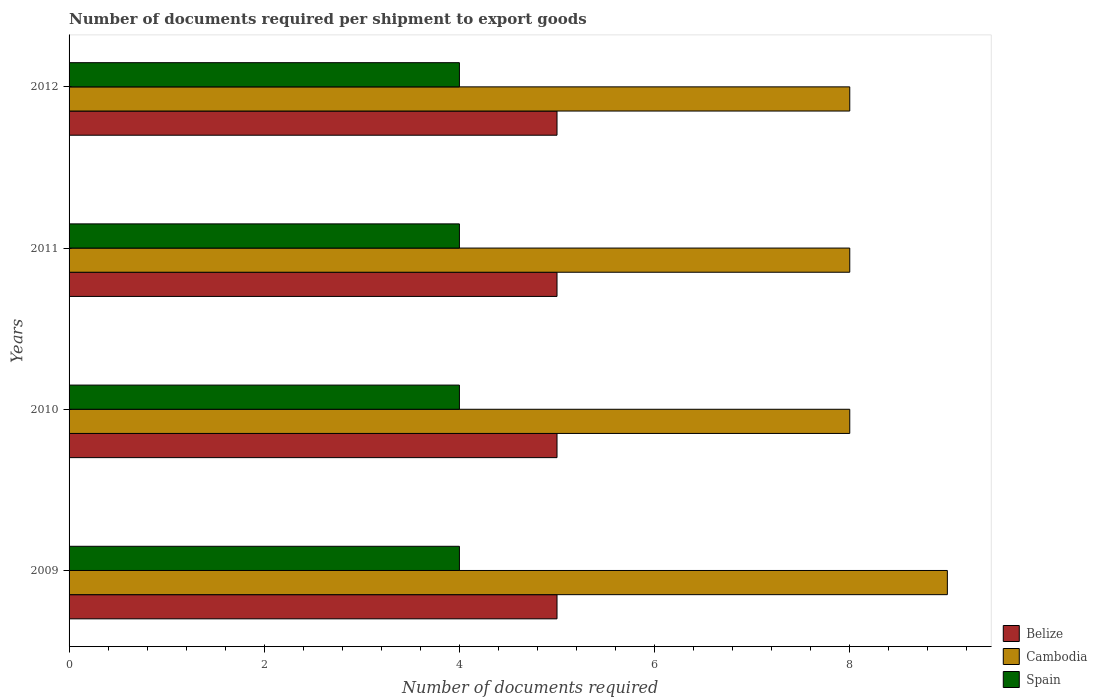How many groups of bars are there?
Your answer should be very brief. 4. Are the number of bars per tick equal to the number of legend labels?
Offer a very short reply. Yes. How many bars are there on the 2nd tick from the top?
Your answer should be very brief. 3. In how many cases, is the number of bars for a given year not equal to the number of legend labels?
Ensure brevity in your answer.  0. What is the number of documents required per shipment to export goods in Spain in 2012?
Your answer should be very brief. 4. Across all years, what is the maximum number of documents required per shipment to export goods in Belize?
Offer a terse response. 5. Across all years, what is the minimum number of documents required per shipment to export goods in Cambodia?
Make the answer very short. 8. In which year was the number of documents required per shipment to export goods in Belize maximum?
Your answer should be very brief. 2009. In which year was the number of documents required per shipment to export goods in Cambodia minimum?
Provide a succinct answer. 2010. What is the total number of documents required per shipment to export goods in Cambodia in the graph?
Provide a succinct answer. 33. What is the difference between the number of documents required per shipment to export goods in Cambodia in 2009 and that in 2010?
Give a very brief answer. 1. What is the difference between the number of documents required per shipment to export goods in Belize in 2010 and the number of documents required per shipment to export goods in Spain in 2011?
Provide a succinct answer. 1. In the year 2010, what is the difference between the number of documents required per shipment to export goods in Spain and number of documents required per shipment to export goods in Cambodia?
Your response must be concise. -4. In how many years, is the number of documents required per shipment to export goods in Belize greater than 3.6 ?
Provide a succinct answer. 4. Is the number of documents required per shipment to export goods in Cambodia in 2009 less than that in 2010?
Offer a very short reply. No. Is the difference between the number of documents required per shipment to export goods in Spain in 2010 and 2012 greater than the difference between the number of documents required per shipment to export goods in Cambodia in 2010 and 2012?
Keep it short and to the point. No. In how many years, is the number of documents required per shipment to export goods in Belize greater than the average number of documents required per shipment to export goods in Belize taken over all years?
Give a very brief answer. 0. What does the 2nd bar from the top in 2012 represents?
Your response must be concise. Cambodia. What does the 1st bar from the bottom in 2011 represents?
Provide a short and direct response. Belize. Is it the case that in every year, the sum of the number of documents required per shipment to export goods in Spain and number of documents required per shipment to export goods in Cambodia is greater than the number of documents required per shipment to export goods in Belize?
Offer a terse response. Yes. What is the difference between two consecutive major ticks on the X-axis?
Keep it short and to the point. 2. Where does the legend appear in the graph?
Keep it short and to the point. Bottom right. How are the legend labels stacked?
Ensure brevity in your answer.  Vertical. What is the title of the graph?
Ensure brevity in your answer.  Number of documents required per shipment to export goods. Does "Guatemala" appear as one of the legend labels in the graph?
Keep it short and to the point. No. What is the label or title of the X-axis?
Make the answer very short. Number of documents required. What is the label or title of the Y-axis?
Your answer should be very brief. Years. What is the Number of documents required in Belize in 2009?
Make the answer very short. 5. What is the Number of documents required of Spain in 2009?
Your answer should be very brief. 4. What is the Number of documents required in Belize in 2010?
Your answer should be very brief. 5. What is the Number of documents required of Spain in 2010?
Your answer should be very brief. 4. What is the Number of documents required in Belize in 2011?
Make the answer very short. 5. What is the Number of documents required in Cambodia in 2011?
Ensure brevity in your answer.  8. What is the Number of documents required in Belize in 2012?
Offer a very short reply. 5. What is the Number of documents required of Spain in 2012?
Give a very brief answer. 4. Across all years, what is the maximum Number of documents required of Belize?
Your response must be concise. 5. Across all years, what is the maximum Number of documents required of Cambodia?
Make the answer very short. 9. Across all years, what is the maximum Number of documents required of Spain?
Your answer should be very brief. 4. Across all years, what is the minimum Number of documents required in Spain?
Your response must be concise. 4. What is the total Number of documents required of Cambodia in the graph?
Make the answer very short. 33. What is the difference between the Number of documents required in Belize in 2009 and that in 2010?
Make the answer very short. 0. What is the difference between the Number of documents required of Belize in 2009 and that in 2011?
Your answer should be compact. 0. What is the difference between the Number of documents required of Cambodia in 2009 and that in 2011?
Your response must be concise. 1. What is the difference between the Number of documents required in Belize in 2009 and that in 2012?
Your answer should be compact. 0. What is the difference between the Number of documents required of Spain in 2010 and that in 2011?
Provide a succinct answer. 0. What is the difference between the Number of documents required in Cambodia in 2009 and the Number of documents required in Spain in 2010?
Offer a terse response. 5. What is the difference between the Number of documents required of Belize in 2009 and the Number of documents required of Cambodia in 2011?
Your answer should be compact. -3. What is the difference between the Number of documents required in Belize in 2009 and the Number of documents required in Spain in 2011?
Your answer should be very brief. 1. What is the difference between the Number of documents required of Cambodia in 2009 and the Number of documents required of Spain in 2011?
Ensure brevity in your answer.  5. What is the difference between the Number of documents required in Belize in 2009 and the Number of documents required in Spain in 2012?
Offer a terse response. 1. What is the difference between the Number of documents required in Belize in 2010 and the Number of documents required in Spain in 2011?
Provide a short and direct response. 1. What is the difference between the Number of documents required of Belize in 2010 and the Number of documents required of Cambodia in 2012?
Your answer should be very brief. -3. What is the difference between the Number of documents required in Cambodia in 2010 and the Number of documents required in Spain in 2012?
Offer a very short reply. 4. What is the difference between the Number of documents required in Belize in 2011 and the Number of documents required in Spain in 2012?
Ensure brevity in your answer.  1. What is the average Number of documents required in Cambodia per year?
Offer a terse response. 8.25. What is the average Number of documents required in Spain per year?
Your response must be concise. 4. In the year 2009, what is the difference between the Number of documents required of Belize and Number of documents required of Cambodia?
Your response must be concise. -4. In the year 2009, what is the difference between the Number of documents required in Cambodia and Number of documents required in Spain?
Provide a succinct answer. 5. In the year 2010, what is the difference between the Number of documents required of Belize and Number of documents required of Spain?
Keep it short and to the point. 1. In the year 2010, what is the difference between the Number of documents required of Cambodia and Number of documents required of Spain?
Offer a terse response. 4. In the year 2011, what is the difference between the Number of documents required of Belize and Number of documents required of Cambodia?
Offer a very short reply. -3. In the year 2011, what is the difference between the Number of documents required in Belize and Number of documents required in Spain?
Your answer should be compact. 1. In the year 2012, what is the difference between the Number of documents required of Belize and Number of documents required of Cambodia?
Provide a short and direct response. -3. What is the ratio of the Number of documents required in Belize in 2009 to that in 2010?
Your response must be concise. 1. What is the ratio of the Number of documents required of Spain in 2009 to that in 2010?
Your response must be concise. 1. What is the ratio of the Number of documents required in Cambodia in 2009 to that in 2012?
Your response must be concise. 1.12. What is the ratio of the Number of documents required in Cambodia in 2010 to that in 2011?
Your answer should be compact. 1. What is the ratio of the Number of documents required of Spain in 2010 to that in 2011?
Offer a terse response. 1. What is the ratio of the Number of documents required in Cambodia in 2010 to that in 2012?
Your response must be concise. 1. What is the ratio of the Number of documents required of Spain in 2010 to that in 2012?
Provide a succinct answer. 1. What is the ratio of the Number of documents required in Belize in 2011 to that in 2012?
Offer a terse response. 1. What is the ratio of the Number of documents required in Cambodia in 2011 to that in 2012?
Your answer should be compact. 1. What is the difference between the highest and the lowest Number of documents required of Spain?
Your answer should be compact. 0. 